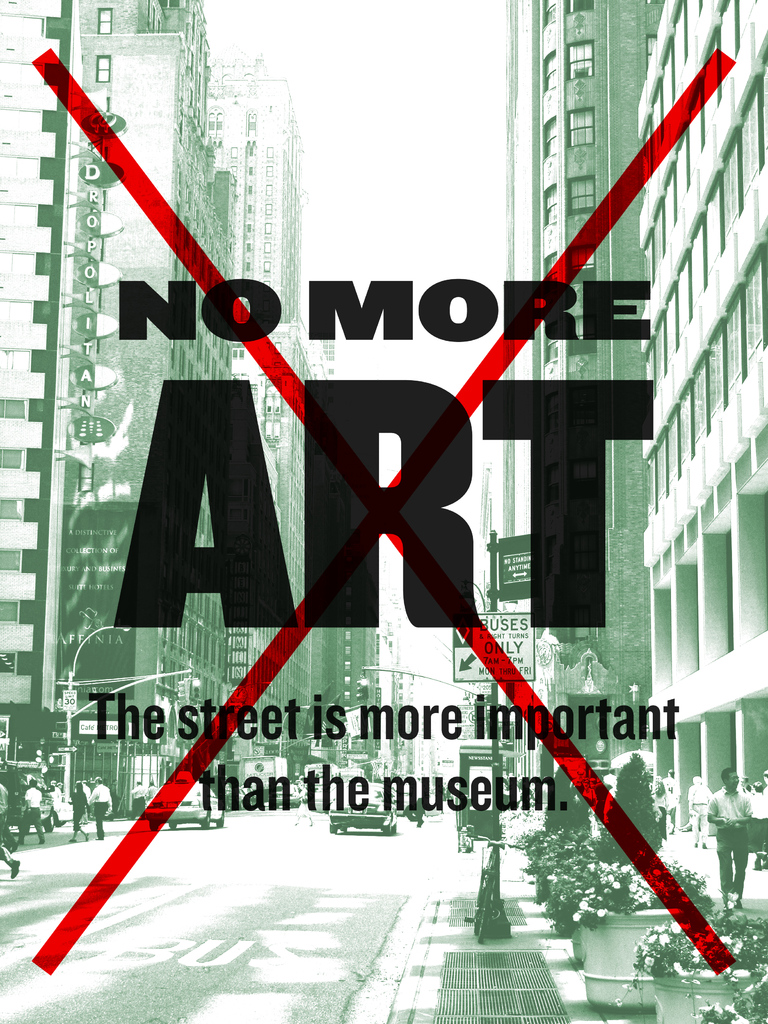What do you see happening in this image? The image captures a bold artistic protest, prominently featuring a poster with the stark message 'No More Art'. This is overlaid on a vibrant photograph of a city street, suggesting a juxtaposition of life outside traditional art confines. The secondary message, 'The street is more important than the museum', underscores a critical viewpoint on the role and accessibility of art in society. The red 'X' crossing out the image intensifies this message, symbolizing a rejection of the status quo and urging a shift to more engaging, public forms of expression. This protest is against conventional art venues and advocates for a transformation in how art integrates into everyday life. 